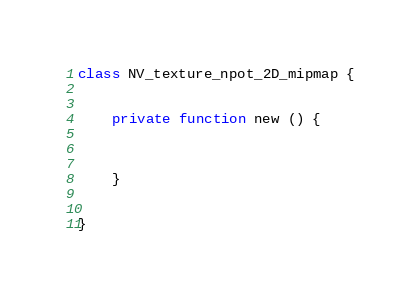<code> <loc_0><loc_0><loc_500><loc_500><_Haxe_>
class NV_texture_npot_2D_mipmap {
	
	
	private function new () {
		
		
		
	}
	
	
}</code> 